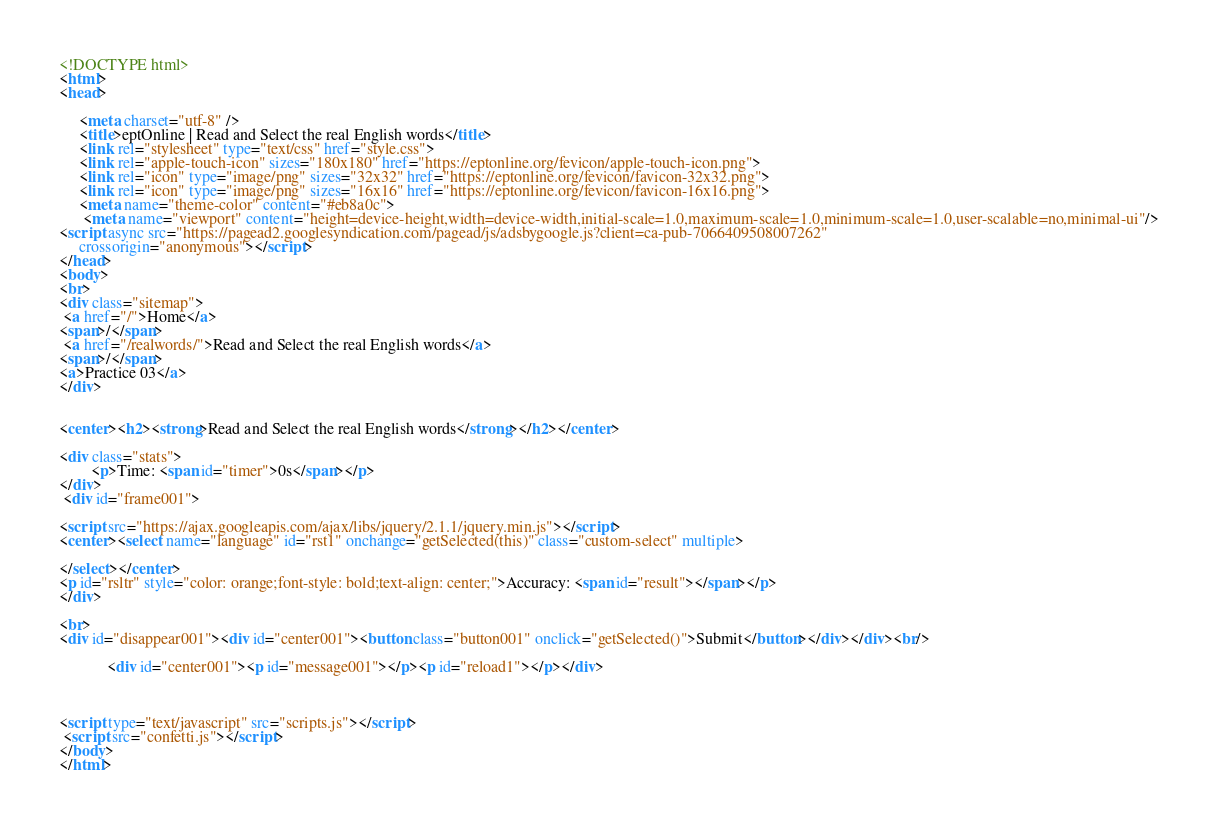Convert code to text. <code><loc_0><loc_0><loc_500><loc_500><_HTML_><!DOCTYPE html>
<html>
<head>
	
	 <meta charset="utf-8" />
	 <title>eptOnline | Read and Select the real English words</title>
	 <link rel="stylesheet" type="text/css" href="style.css">
   	 <link rel="apple-touch-icon" sizes="180x180" href="https://eptonline.org/fevicon/apple-touch-icon.png">
   	 <link rel="icon" type="image/png" sizes="32x32" href="https://eptonline.org/fevicon/favicon-32x32.png">
   	 <link rel="icon" type="image/png" sizes="16x16" href="https://eptonline.org/fevicon/favicon-16x16.png">
   	 <meta name="theme-color" content="#eb8a0c">
  	  <meta name="viewport" content="height=device-height,width=device-width,initial-scale=1.0,maximum-scale=1.0,minimum-scale=1.0,user-scalable=no,minimal-ui"/>
<script async src="https://pagead2.googlesyndication.com/pagead/js/adsbygoogle.js?client=ca-pub-7066409508007262"
     crossorigin="anonymous"></script>
</head>
<body>
<br>
<div class="sitemap">
 <a href="/">Home</a>
<span>/</span>
 <a href="/realwords/">Read and Select the real English words</a>
<span>/</span>
<a>Practice 03</a>
</div> 


<center><h2><strong>Read and Select the real English words</strong></h2></center>

<div class="stats">
        <p>Time: <span id="timer">0s</span></p>
</div>
 <div id="frame001">
  
<script src="https://ajax.googleapis.com/ajax/libs/jquery/2.1.1/jquery.min.js"></script>
<center><select name="language" id="rst1" onchange="getSelected(this)" class="custom-select" multiple>

</select></center>
<p id="rsltr" style="color: orange;font-style: bold;text-align: center;">Accuracy: <span id="result"></span></p>
</div>

<br>
<div id="disappear001"><div id="center001"><button class="button001" onclick="getSelected()">Submit</button></div></div><br/>
          
            <div id="center001"><p id="message001"></p><p id="reload1"></p></div>



<script type="text/javascript" src="scripts.js"></script>
 <script src="confetti.js"></script>
</body>
</html>
</code> 